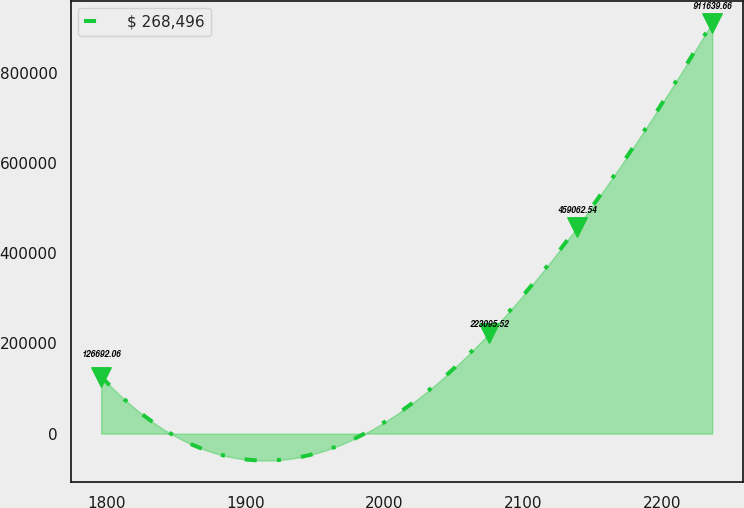Convert chart. <chart><loc_0><loc_0><loc_500><loc_500><line_chart><ecel><fcel>$ 268,496<nl><fcel>1796.14<fcel>126692<nl><fcel>2075.63<fcel>223096<nl><fcel>2138.94<fcel>459063<nl><fcel>2235.94<fcel>911640<nl></chart> 